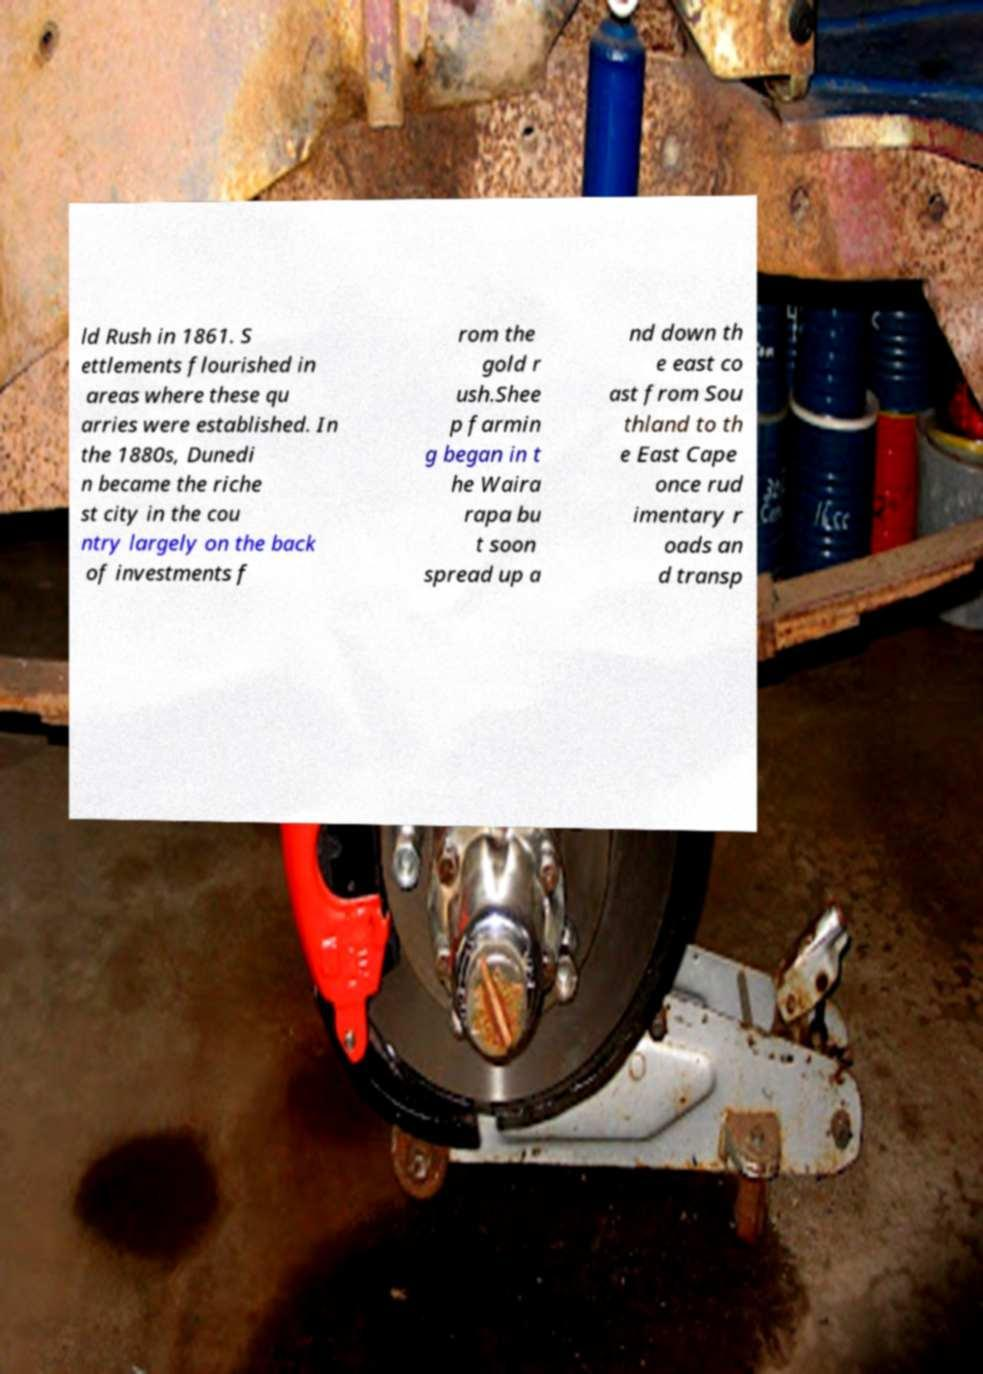Please read and relay the text visible in this image. What does it say? ld Rush in 1861. S ettlements flourished in areas where these qu arries were established. In the 1880s, Dunedi n became the riche st city in the cou ntry largely on the back of investments f rom the gold r ush.Shee p farmin g began in t he Waira rapa bu t soon spread up a nd down th e east co ast from Sou thland to th e East Cape once rud imentary r oads an d transp 